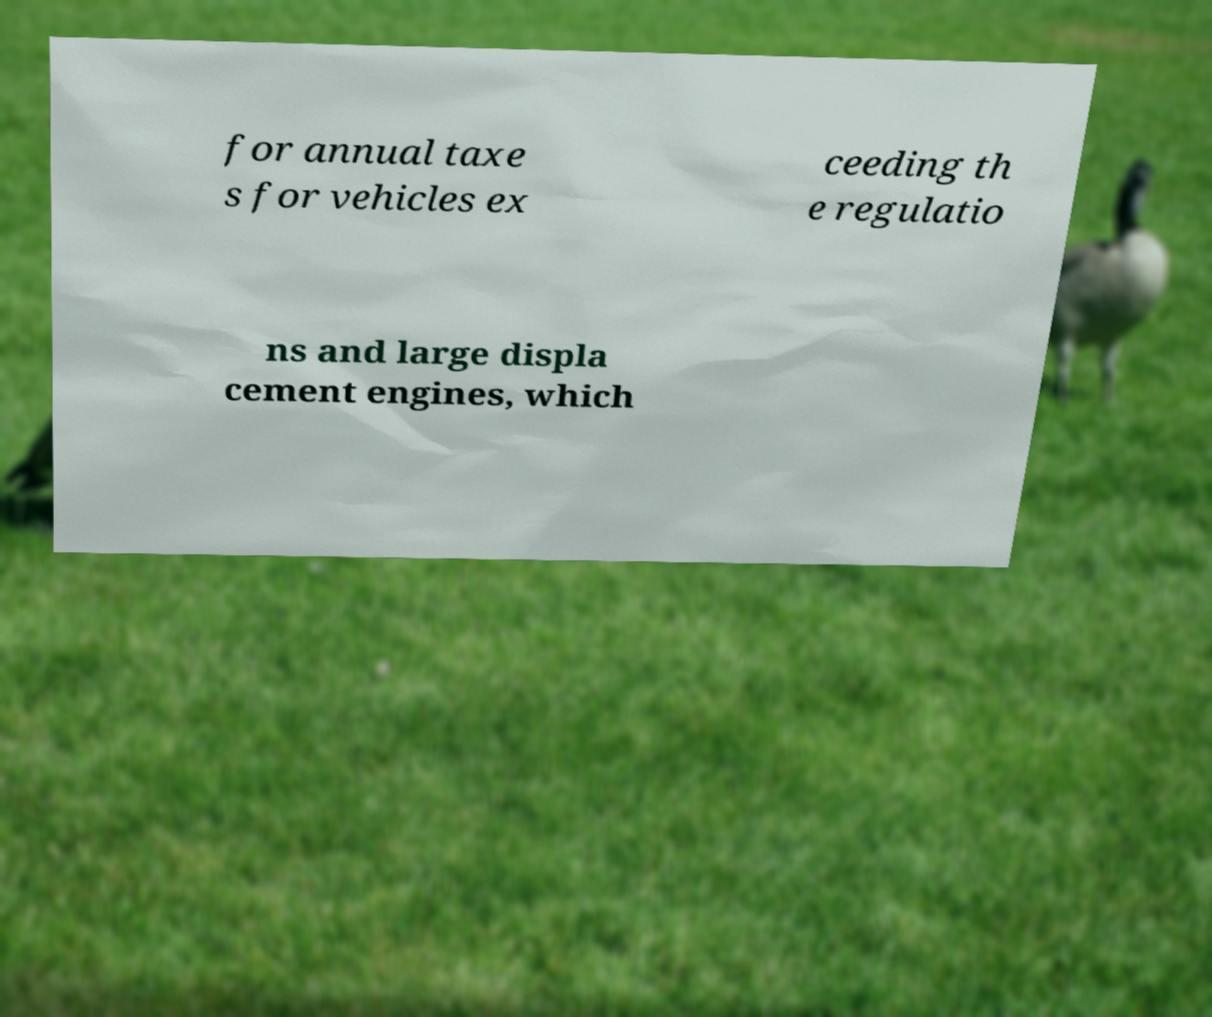For documentation purposes, I need the text within this image transcribed. Could you provide that? for annual taxe s for vehicles ex ceeding th e regulatio ns and large displa cement engines, which 